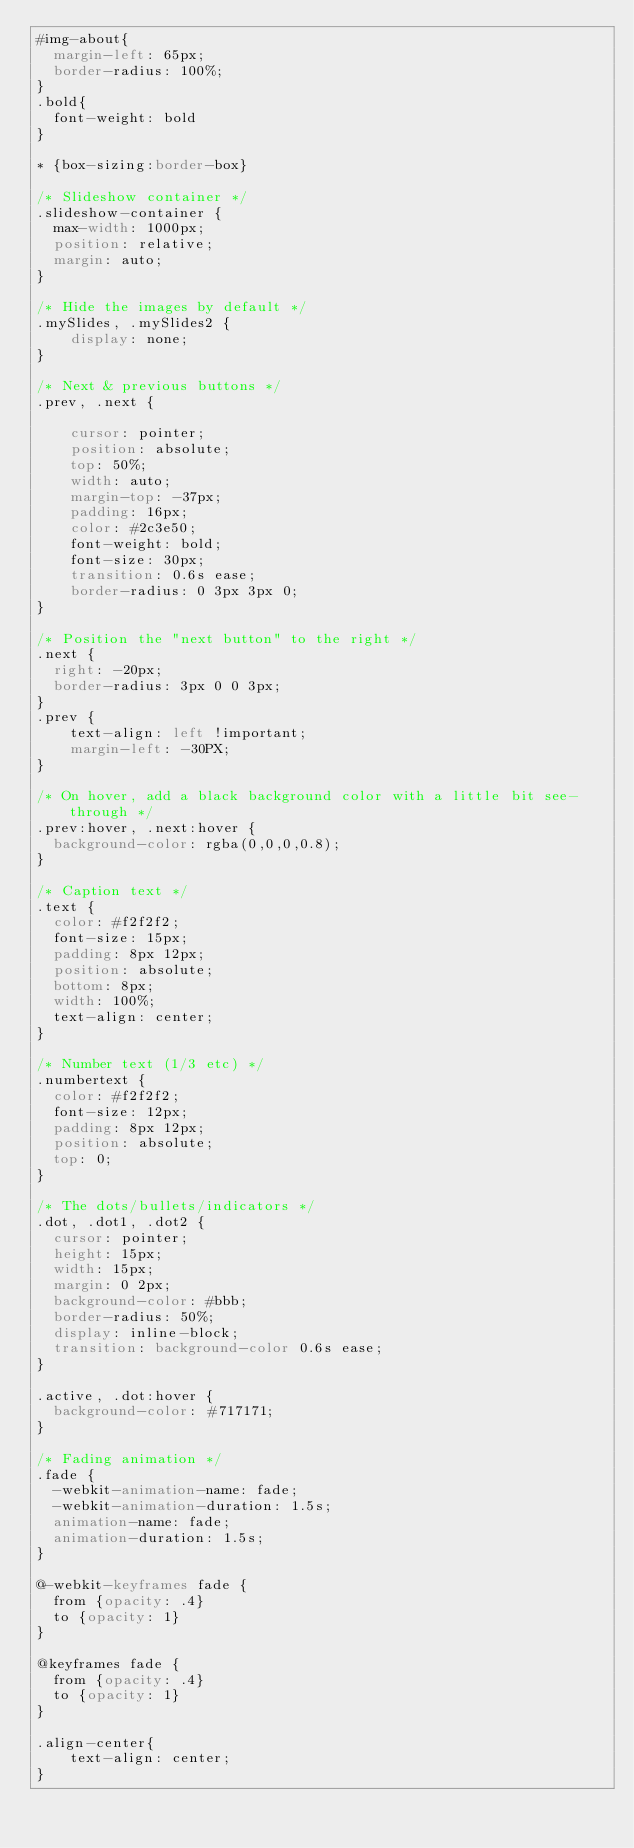<code> <loc_0><loc_0><loc_500><loc_500><_CSS_>#img-about{
  margin-left: 65px;
  border-radius: 100%;
}
.bold{
  font-weight: bold
}

* {box-sizing:border-box}

/* Slideshow container */
.slideshow-container {
  max-width: 1000px;
  position: relative;
  margin: auto;
}

/* Hide the images by default */
.mySlides, .mySlides2 {
    display: none;
}

/* Next & previous buttons */
.prev, .next {
  
    cursor: pointer;
    position: absolute;
    top: 50%;
    width: auto;
    margin-top: -37px;
    padding: 16px;
    color: #2c3e50;
    font-weight: bold;
    font-size: 30px;
    transition: 0.6s ease;
    border-radius: 0 3px 3px 0;
}

/* Position the "next button" to the right */
.next {
  right: -20px;
  border-radius: 3px 0 0 3px;  
}
.prev {
	text-align: left !important; 
	margin-left: -30PX;
}

/* On hover, add a black background color with a little bit see-through */
.prev:hover, .next:hover {
  background-color: rgba(0,0,0,0.8);
}

/* Caption text */
.text {
  color: #f2f2f2;
  font-size: 15px;
  padding: 8px 12px;
  position: absolute;
  bottom: 8px;
  width: 100%;
  text-align: center;
}

/* Number text (1/3 etc) */
.numbertext {
  color: #f2f2f2;
  font-size: 12px;
  padding: 8px 12px;
  position: absolute;
  top: 0;
}

/* The dots/bullets/indicators */
.dot, .dot1, .dot2 {
  cursor: pointer;
  height: 15px;
  width: 15px;
  margin: 0 2px;
  background-color: #bbb;
  border-radius: 50%;
  display: inline-block;
  transition: background-color 0.6s ease;
}

.active, .dot:hover {
  background-color: #717171;
}

/* Fading animation */
.fade {
  -webkit-animation-name: fade;
  -webkit-animation-duration: 1.5s;
  animation-name: fade;
  animation-duration: 1.5s;
}

@-webkit-keyframes fade {
  from {opacity: .4} 
  to {opacity: 1}
}

@keyframes fade {
  from {opacity: .4} 
  to {opacity: 1}
}

.align-center{
	text-align: center;
}

</code> 